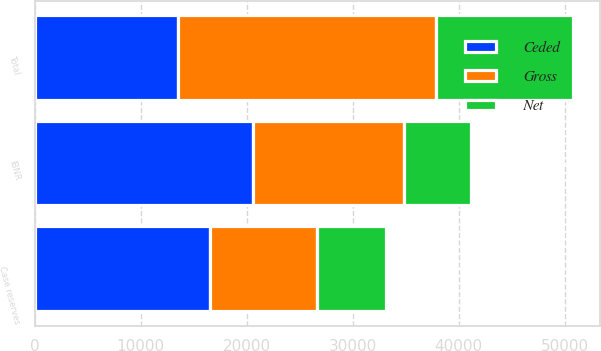<chart> <loc_0><loc_0><loc_500><loc_500><stacked_bar_chart><ecel><fcel>Case reserves<fcel>IBNR<fcel>Total<nl><fcel>Ceded<fcel>16583<fcel>20593<fcel>13566<nl><fcel>Net<fcel>6539<fcel>6396<fcel>12935<nl><fcel>Gross<fcel>10044<fcel>14197<fcel>24241<nl></chart> 